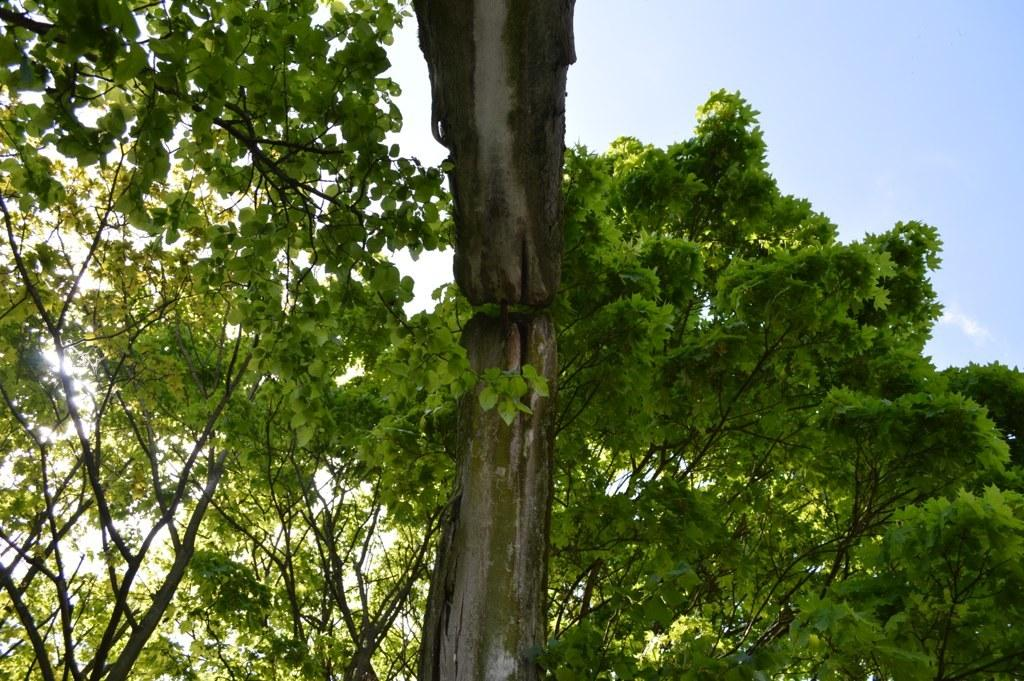What type of vegetation can be seen in the image? There are trees in the image. What is the color of the trees? The trees are green in color. What else is visible in the image besides the trees? The sky is visible in the image. What colors can be seen in the sky? The sky is blue and white in color. Is there a bridge visible in the image? No, there is no bridge present in the image. How does the growth of the trees affect the landscape in the image? The growth of the trees is not mentioned in the provided facts, so it cannot be determined how it affects the landscape in the image. 